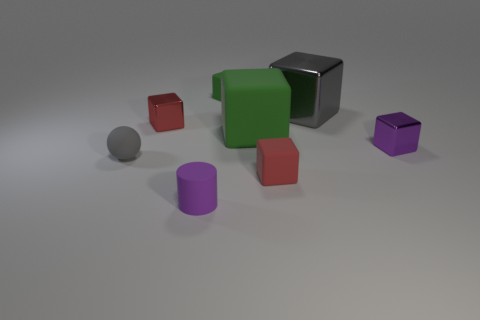There is a cube that is the same color as the cylinder; what is its material?
Offer a very short reply. Metal. Is the number of large green matte objects that are in front of the rubber ball less than the number of big gray objects that are behind the rubber cylinder?
Your response must be concise. Yes. What number of objects are either small rubber blocks that are behind the big green thing or small green metallic balls?
Provide a succinct answer. 1. What shape is the tiny rubber object that is behind the small metallic cube that is behind the tiny purple shiny cube?
Provide a short and direct response. Cube. Are there any purple shiny objects that have the same size as the red matte object?
Your answer should be very brief. Yes. Is the number of green blocks greater than the number of tiny gray matte objects?
Give a very brief answer. Yes. Does the red thing behind the tiny gray ball have the same size as the purple object that is right of the large matte object?
Keep it short and to the point. Yes. How many things are both left of the big gray object and in front of the large gray cube?
Provide a short and direct response. 5. There is another big rubber object that is the same shape as the red rubber object; what color is it?
Your answer should be compact. Green. Are there fewer green cubes than tiny green cylinders?
Your answer should be compact. No. 